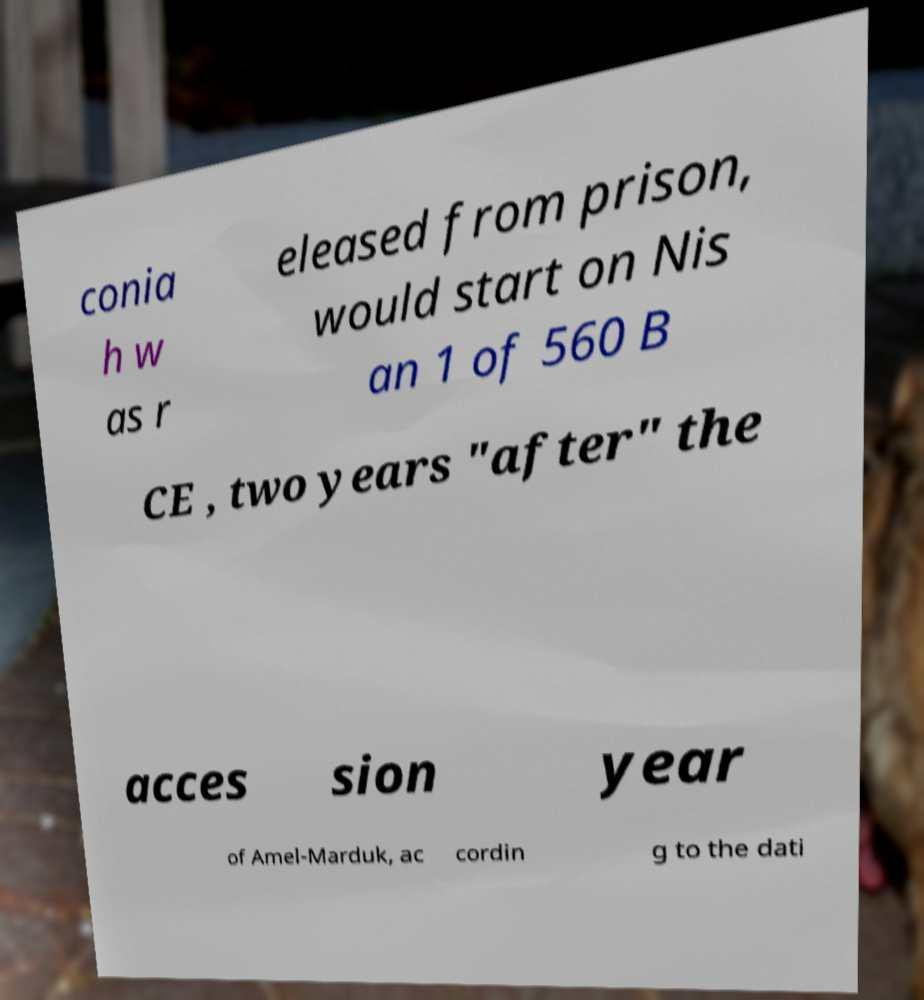For documentation purposes, I need the text within this image transcribed. Could you provide that? conia h w as r eleased from prison, would start on Nis an 1 of 560 B CE , two years "after" the acces sion year of Amel-Marduk, ac cordin g to the dati 